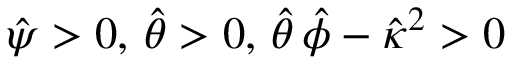<formula> <loc_0><loc_0><loc_500><loc_500>\hat { \psi } > 0 , \, \hat { \theta } > 0 , \, \hat { \theta } \, \hat { \phi } - \hat { \kappa } ^ { 2 } > 0</formula> 